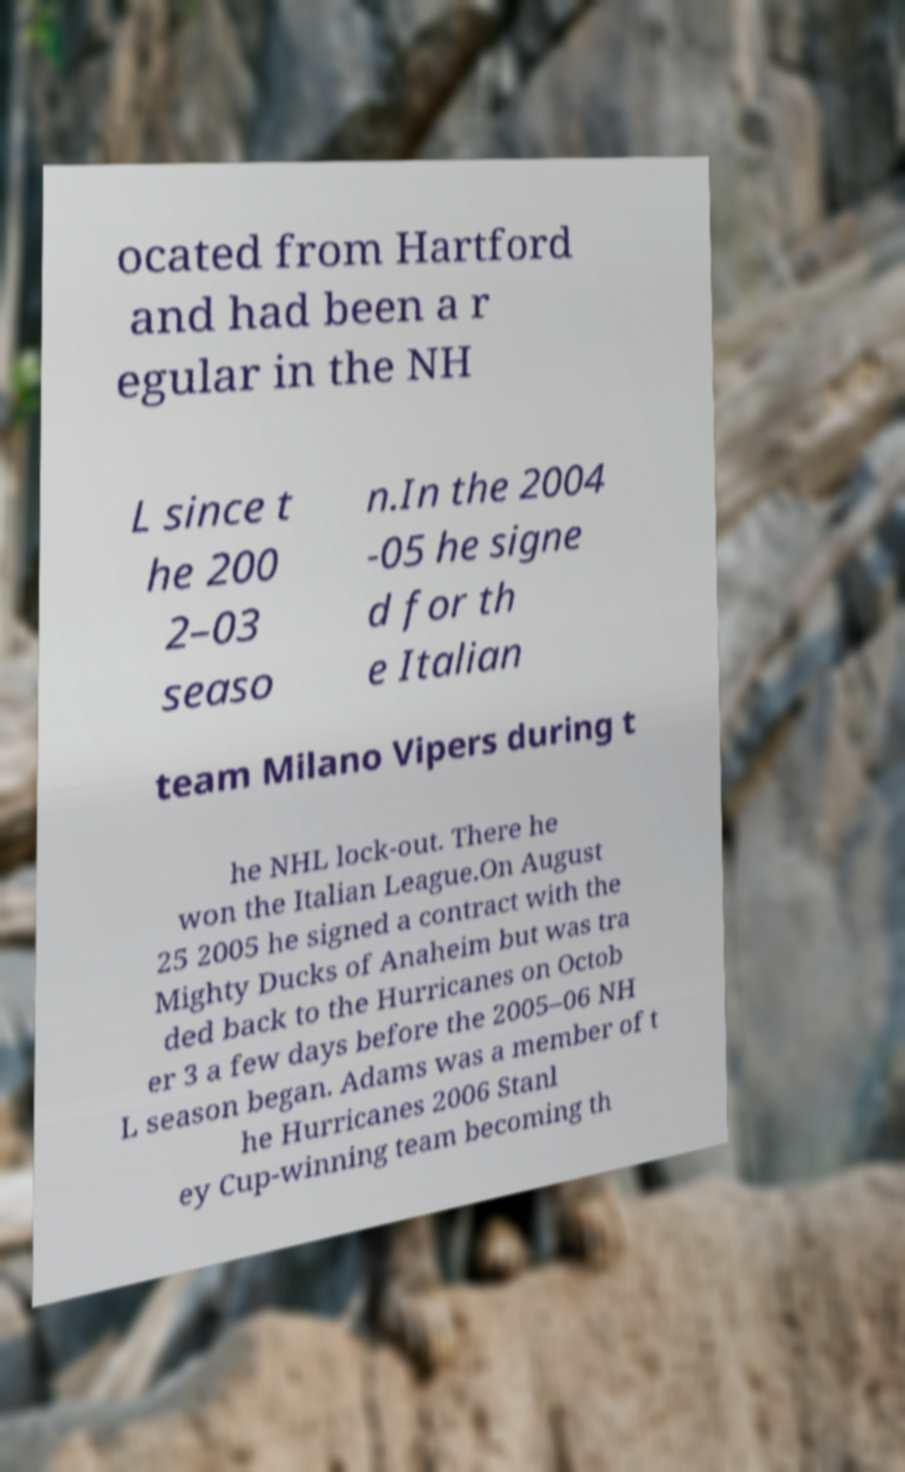For documentation purposes, I need the text within this image transcribed. Could you provide that? ocated from Hartford and had been a r egular in the NH L since t he 200 2–03 seaso n.In the 2004 -05 he signe d for th e Italian team Milano Vipers during t he NHL lock-out. There he won the Italian League.On August 25 2005 he signed a contract with the Mighty Ducks of Anaheim but was tra ded back to the Hurricanes on Octob er 3 a few days before the 2005–06 NH L season began. Adams was a member of t he Hurricanes 2006 Stanl ey Cup-winning team becoming th 